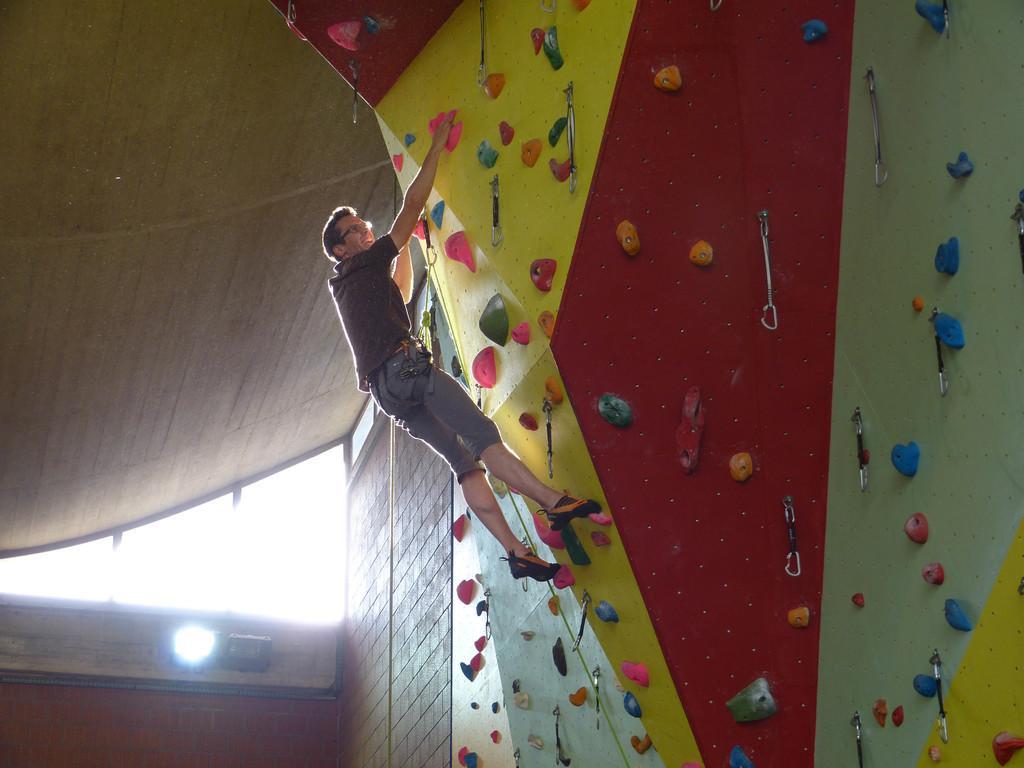Can you describe this image briefly? A person is climbing the wall. To that wall there are chains. At the left side of the image we can see roof, walls and light. 